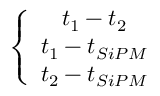<formula> <loc_0><loc_0><loc_500><loc_500>\left \{ \begin{array} { c } { t _ { 1 } - t _ { 2 } } \\ { t _ { 1 } - t _ { S i P M } } \\ { t _ { 2 } - t _ { S i P M } } \end{array}</formula> 